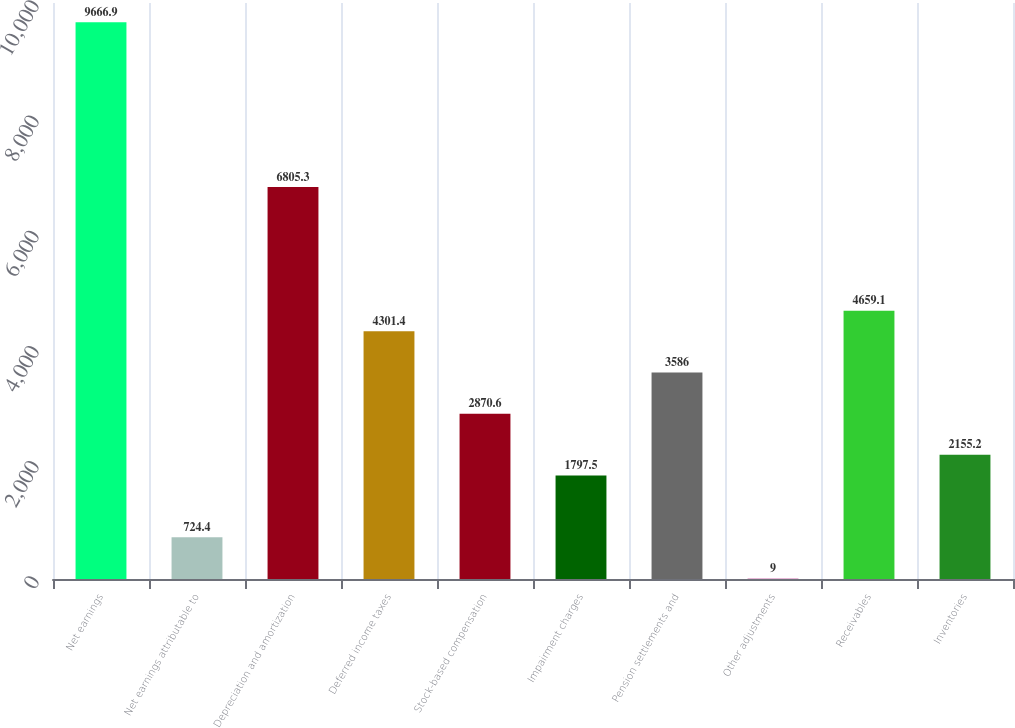Convert chart to OTSL. <chart><loc_0><loc_0><loc_500><loc_500><bar_chart><fcel>Net earnings<fcel>Net earnings attributable to<fcel>Depreciation and amortization<fcel>Deferred income taxes<fcel>Stock-based compensation<fcel>Impairment charges<fcel>Pension settlements and<fcel>Other adjustments<fcel>Receivables<fcel>Inventories<nl><fcel>9666.9<fcel>724.4<fcel>6805.3<fcel>4301.4<fcel>2870.6<fcel>1797.5<fcel>3586<fcel>9<fcel>4659.1<fcel>2155.2<nl></chart> 